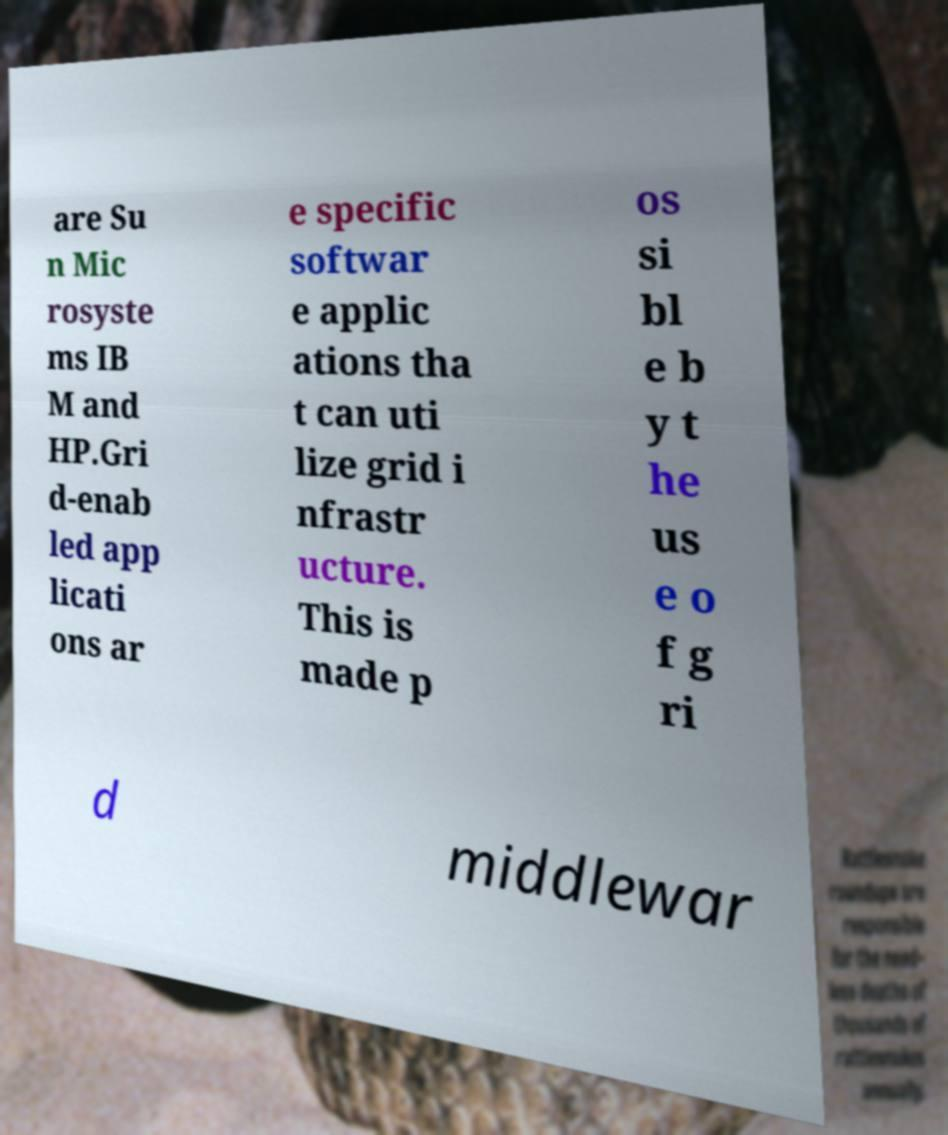Please identify and transcribe the text found in this image. are Su n Mic rosyste ms IB M and HP.Gri d-enab led app licati ons ar e specific softwar e applic ations tha t can uti lize grid i nfrastr ucture. This is made p os si bl e b y t he us e o f g ri d middlewar 